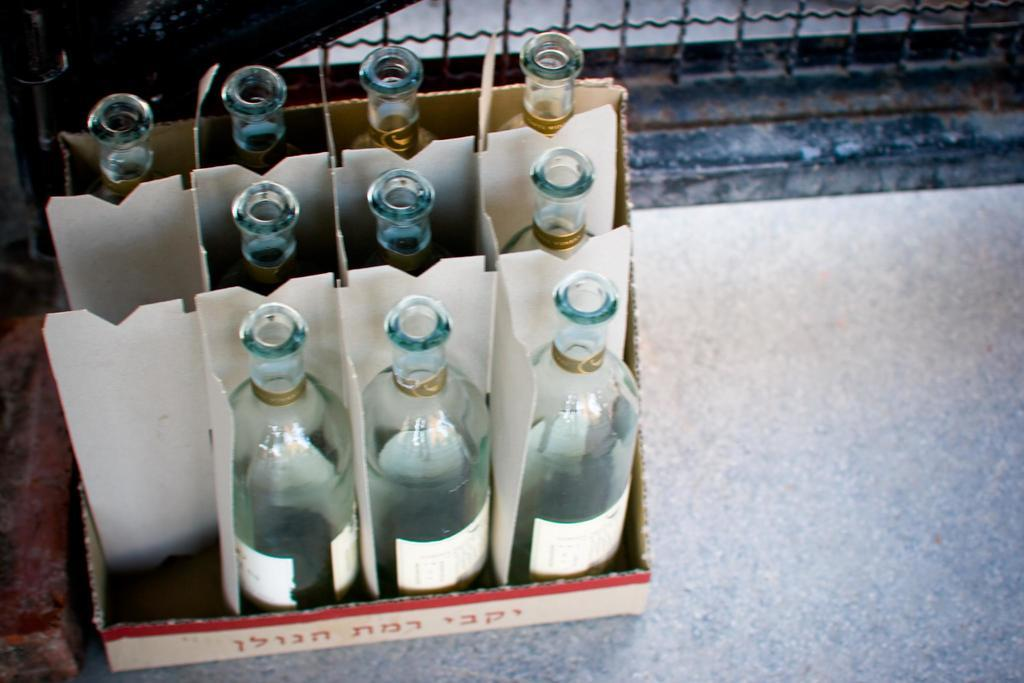What objects are contained within the box in the image? There are bottles in a box in the image. What type of material is used for the fencing behind the box? The fencing behind the box is made of iron. Can you describe the view of the woman in the image? There is no woman present in the image, so it is not possible to describe her view. 